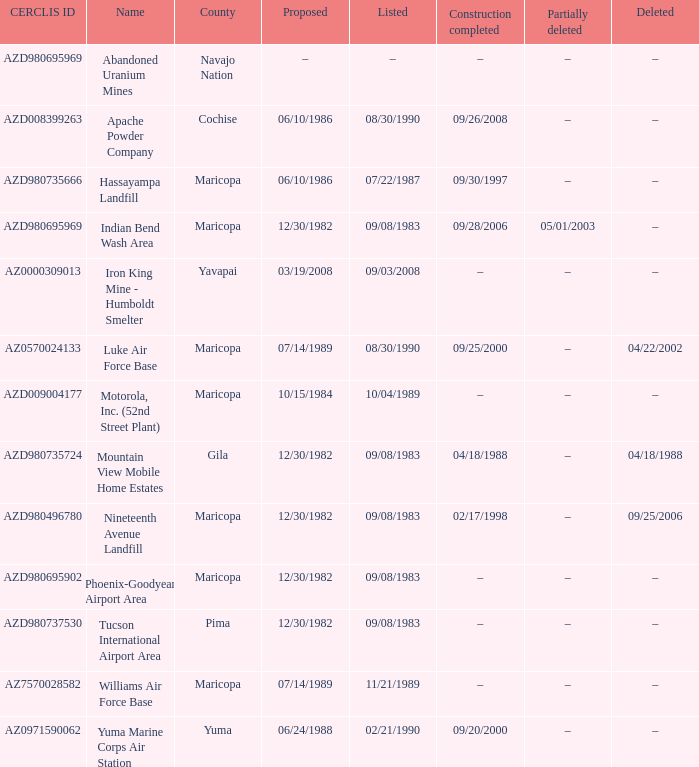When did the site with the cerclis id az7570028582 experience partial deletion? –. Could you parse the entire table? {'header': ['CERCLIS ID', 'Name', 'County', 'Proposed', 'Listed', 'Construction completed', 'Partially deleted', 'Deleted'], 'rows': [['AZD980695969', 'Abandoned Uranium Mines', 'Navajo Nation', '–', '–', '–', '–', '–'], ['AZD008399263', 'Apache Powder Company', 'Cochise', '06/10/1986', '08/30/1990', '09/26/2008', '–', '–'], ['AZD980735666', 'Hassayampa Landfill', 'Maricopa', '06/10/1986', '07/22/1987', '09/30/1997', '–', '–'], ['AZD980695969', 'Indian Bend Wash Area', 'Maricopa', '12/30/1982', '09/08/1983', '09/28/2006', '05/01/2003', '–'], ['AZ0000309013', 'Iron King Mine - Humboldt Smelter', 'Yavapai', '03/19/2008', '09/03/2008', '–', '–', '–'], ['AZ0570024133', 'Luke Air Force Base', 'Maricopa', '07/14/1989', '08/30/1990', '09/25/2000', '–', '04/22/2002'], ['AZD009004177', 'Motorola, Inc. (52nd Street Plant)', 'Maricopa', '10/15/1984', '10/04/1989', '–', '–', '–'], ['AZD980735724', 'Mountain View Mobile Home Estates', 'Gila', '12/30/1982', '09/08/1983', '04/18/1988', '–', '04/18/1988'], ['AZD980496780', 'Nineteenth Avenue Landfill', 'Maricopa', '12/30/1982', '09/08/1983', '02/17/1998', '–', '09/25/2006'], ['AZD980695902', 'Phoenix-Goodyear Airport Area', 'Maricopa', '12/30/1982', '09/08/1983', '–', '–', '–'], ['AZD980737530', 'Tucson International Airport Area', 'Pima', '12/30/1982', '09/08/1983', '–', '–', '–'], ['AZ7570028582', 'Williams Air Force Base', 'Maricopa', '07/14/1989', '11/21/1989', '–', '–', '–'], ['AZ0971590062', 'Yuma Marine Corps Air Station', 'Yuma', '06/24/1988', '02/21/1990', '09/20/2000', '–', '–']]} 